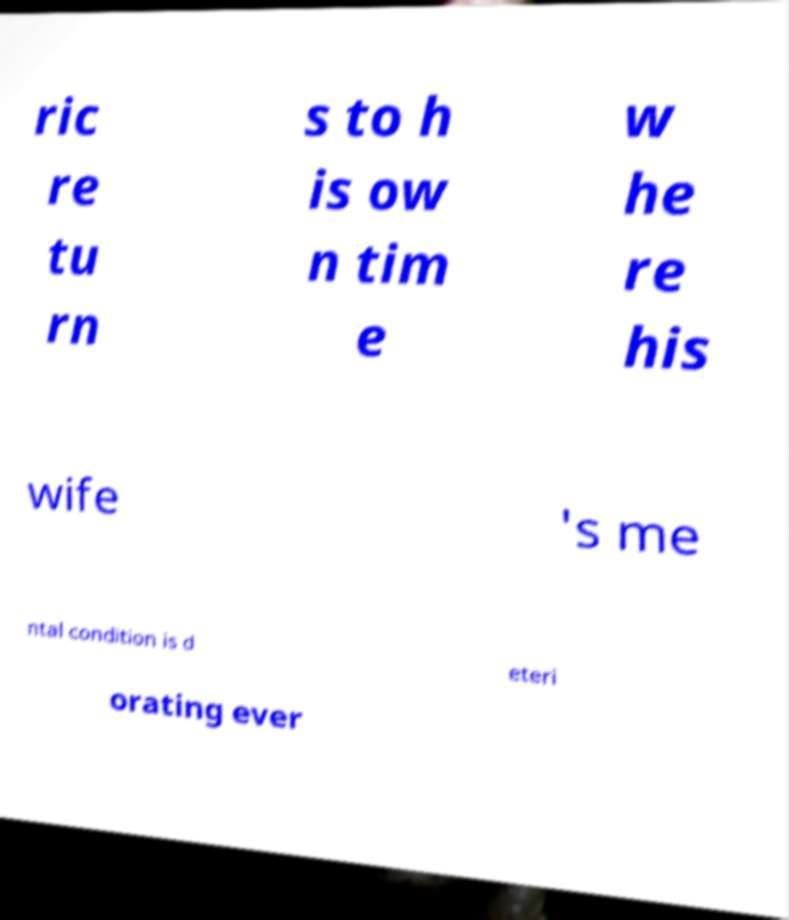What messages or text are displayed in this image? I need them in a readable, typed format. ric re tu rn s to h is ow n tim e w he re his wife 's me ntal condition is d eteri orating ever 